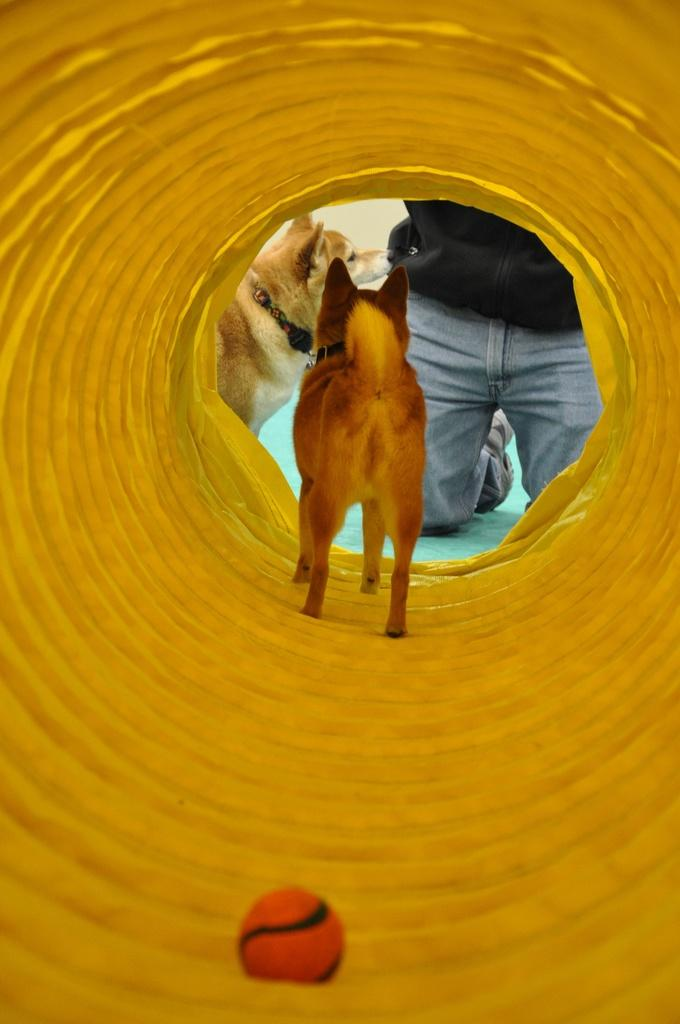How many dogs are in the image? There are two dogs in the image. What is the person in the image doing? The person is kneeling down on the floor. What can be seen in the background of the image? There is a yellow color tunnel in the image. What is inside the tunnel? A ball is present inside the tunnel. What type of roof can be seen on the tunnel in the image? There is no roof visible on the tunnel in the image. Are there any goldfish present in the image? There are no goldfish present in the image. 